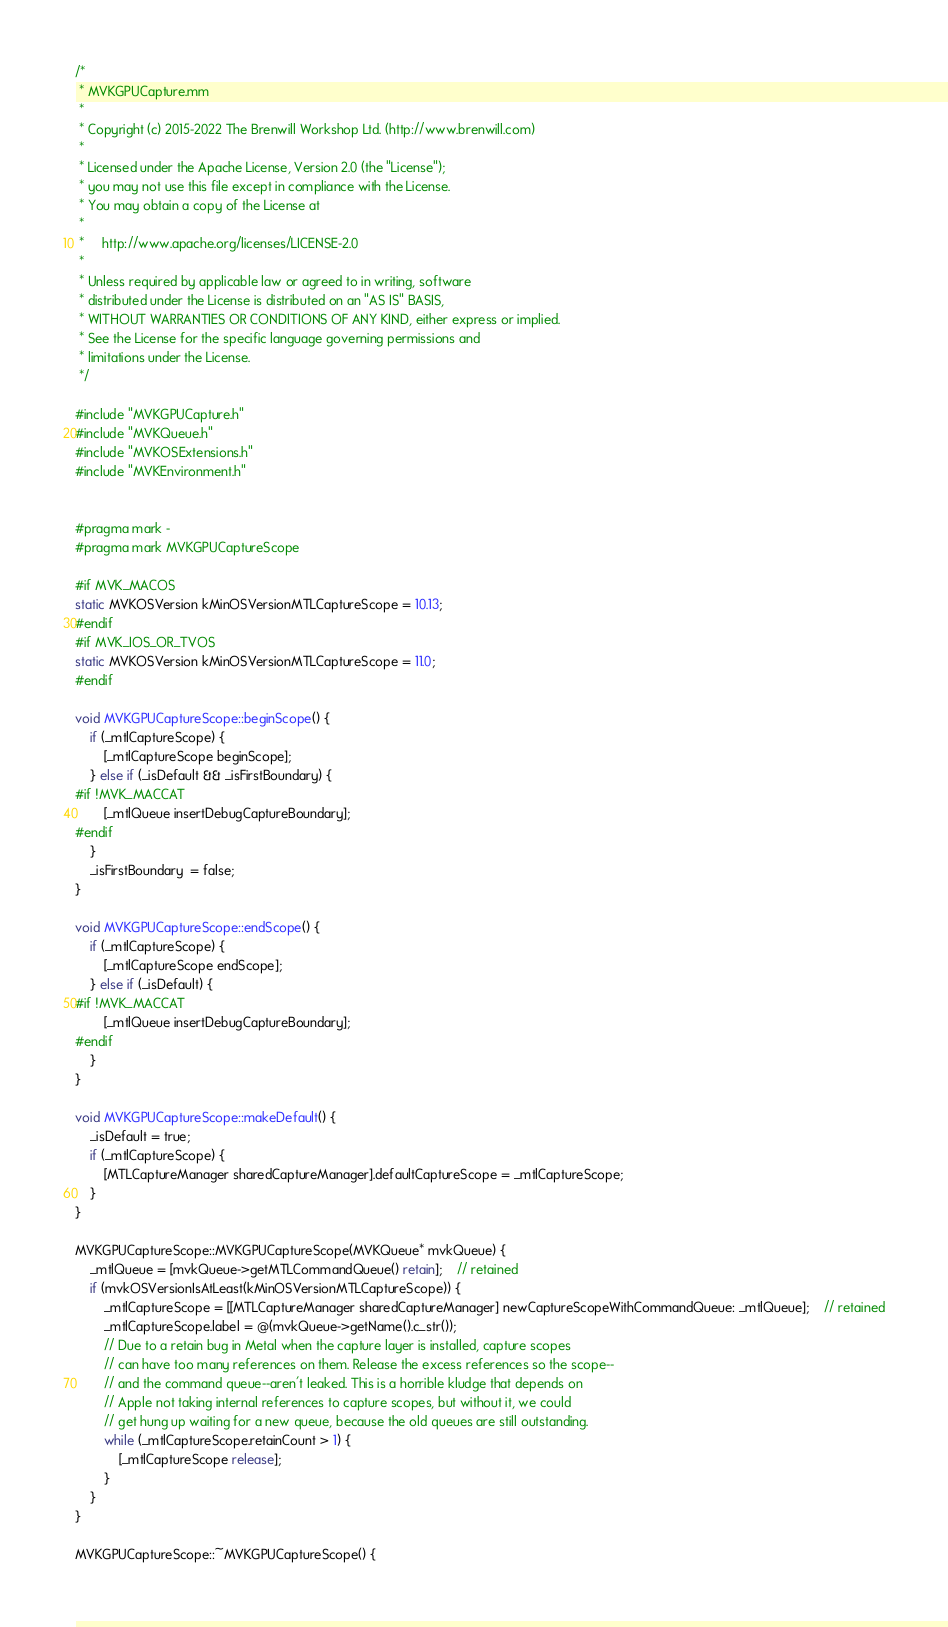Convert code to text. <code><loc_0><loc_0><loc_500><loc_500><_ObjectiveC_>/*
 * MVKGPUCapture.mm
 *
 * Copyright (c) 2015-2022 The Brenwill Workshop Ltd. (http://www.brenwill.com)
 *
 * Licensed under the Apache License, Version 2.0 (the "License");
 * you may not use this file except in compliance with the License.
 * You may obtain a copy of the License at
 * 
 *     http://www.apache.org/licenses/LICENSE-2.0
 * 
 * Unless required by applicable law or agreed to in writing, software
 * distributed under the License is distributed on an "AS IS" BASIS,
 * WITHOUT WARRANTIES OR CONDITIONS OF ANY KIND, either express or implied.
 * See the License for the specific language governing permissions and
 * limitations under the License.
 */

#include "MVKGPUCapture.h"
#include "MVKQueue.h"
#include "MVKOSExtensions.h"
#include "MVKEnvironment.h"


#pragma mark -
#pragma mark MVKGPUCaptureScope

#if MVK_MACOS
static MVKOSVersion kMinOSVersionMTLCaptureScope = 10.13;
#endif
#if MVK_IOS_OR_TVOS
static MVKOSVersion kMinOSVersionMTLCaptureScope = 11.0;
#endif

void MVKGPUCaptureScope::beginScope() {
	if (_mtlCaptureScope) {
		[_mtlCaptureScope beginScope];
	} else if (_isDefault && _isFirstBoundary) {
#if !MVK_MACCAT
		[_mtlQueue insertDebugCaptureBoundary];
#endif
	}
	_isFirstBoundary  = false;
}

void MVKGPUCaptureScope::endScope() {
	if (_mtlCaptureScope) {
		[_mtlCaptureScope endScope];
	} else if (_isDefault) {
#if !MVK_MACCAT
		[_mtlQueue insertDebugCaptureBoundary];
#endif
	}
}

void MVKGPUCaptureScope::makeDefault() {
	_isDefault = true;
	if (_mtlCaptureScope) {
		[MTLCaptureManager sharedCaptureManager].defaultCaptureScope = _mtlCaptureScope;
	}
}

MVKGPUCaptureScope::MVKGPUCaptureScope(MVKQueue* mvkQueue) {
	_mtlQueue = [mvkQueue->getMTLCommandQueue() retain];	// retained
	if (mvkOSVersionIsAtLeast(kMinOSVersionMTLCaptureScope)) {
		_mtlCaptureScope = [[MTLCaptureManager sharedCaptureManager] newCaptureScopeWithCommandQueue: _mtlQueue];	// retained
		_mtlCaptureScope.label = @(mvkQueue->getName().c_str());
		// Due to a retain bug in Metal when the capture layer is installed, capture scopes
		// can have too many references on them. Release the excess references so the scope--
		// and the command queue--aren't leaked. This is a horrible kludge that depends on
		// Apple not taking internal references to capture scopes, but without it, we could
		// get hung up waiting for a new queue, because the old queues are still outstanding.
		while (_mtlCaptureScope.retainCount > 1) {
			[_mtlCaptureScope release];
		}
	}
}

MVKGPUCaptureScope::~MVKGPUCaptureScope() {</code> 